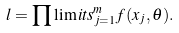<formula> <loc_0><loc_0><loc_500><loc_500>l = \prod \lim i t s _ { j = 1 } ^ { m } { f ( x _ { j } , \theta ) } .</formula> 